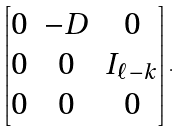Convert formula to latex. <formula><loc_0><loc_0><loc_500><loc_500>\begin{bmatrix} 0 & - D & 0 \\ 0 & 0 & I _ { \ell - k } \\ 0 & 0 & 0 \end{bmatrix} .</formula> 